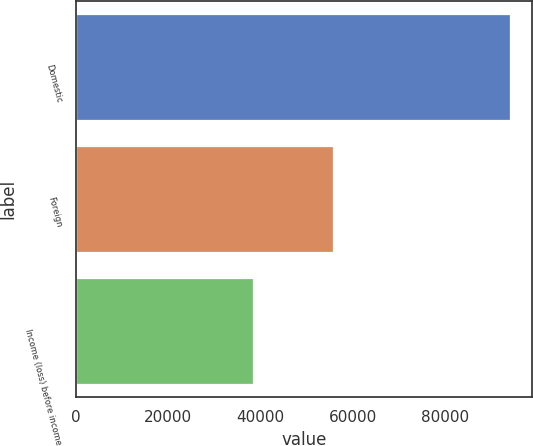Convert chart to OTSL. <chart><loc_0><loc_0><loc_500><loc_500><bar_chart><fcel>Domestic<fcel>Foreign<fcel>Income (loss) before income<nl><fcel>94174<fcel>55824<fcel>38350<nl></chart> 